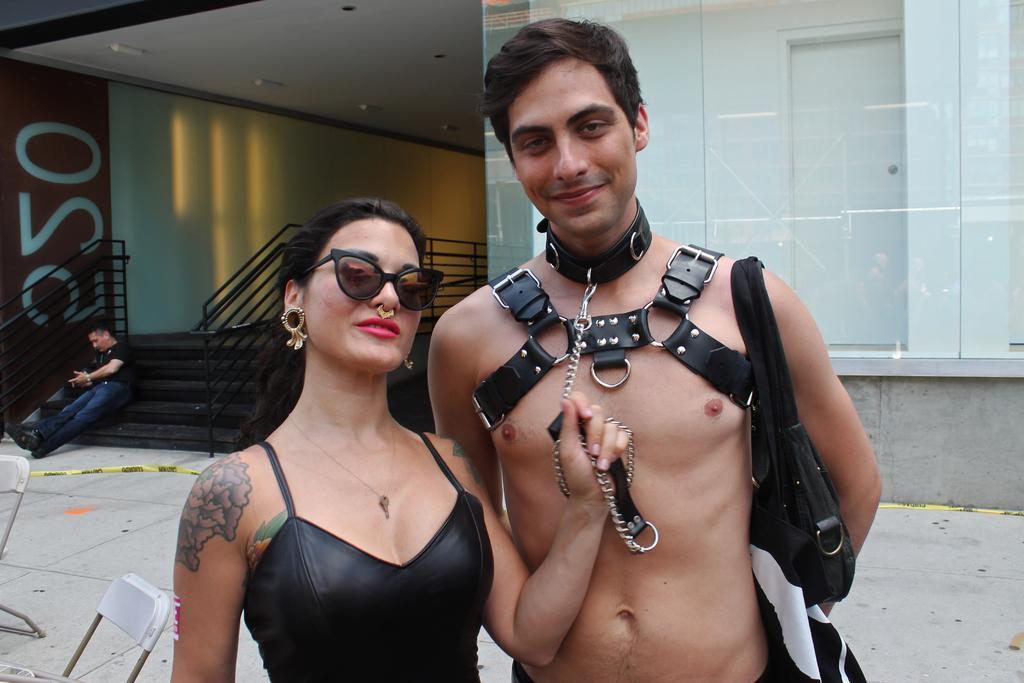In one or two sentences, can you explain what this image depicts? In the middle of the image we can see a man and a woman. She is holding a chain which is attached to a belt. Here we can see chairs, floor, steps, railings, walls, ceiling, lights, glass, and a door. There is a person sitting on the steps. 